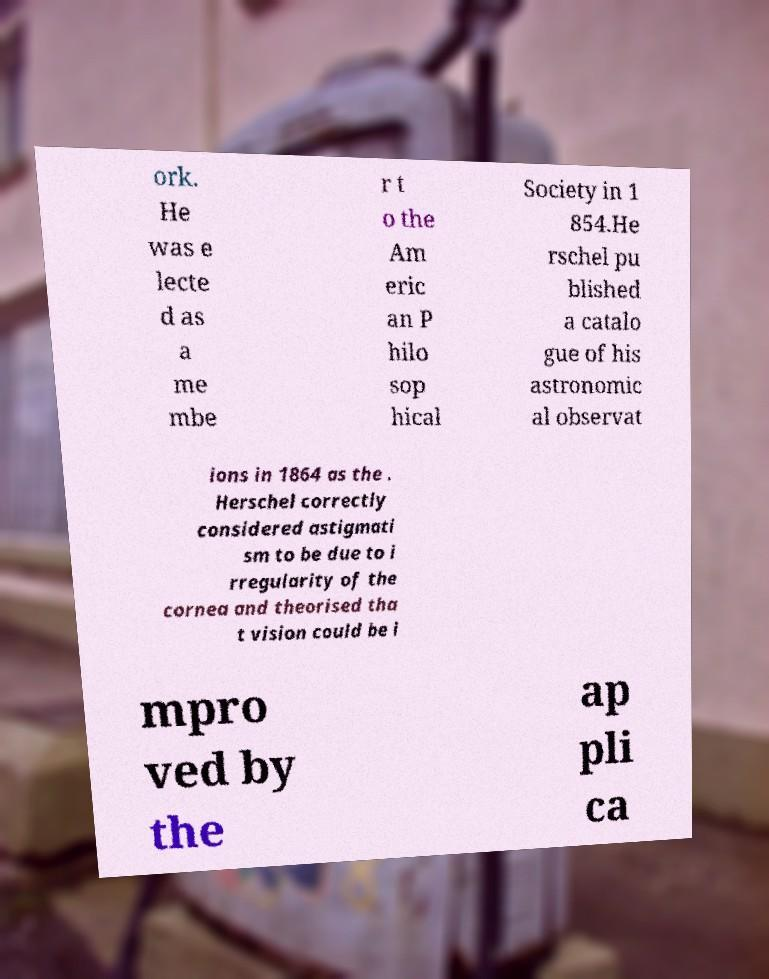Can you read and provide the text displayed in the image?This photo seems to have some interesting text. Can you extract and type it out for me? ork. He was e lecte d as a me mbe r t o the Am eric an P hilo sop hical Society in 1 854.He rschel pu blished a catalo gue of his astronomic al observat ions in 1864 as the . Herschel correctly considered astigmati sm to be due to i rregularity of the cornea and theorised tha t vision could be i mpro ved by the ap pli ca 